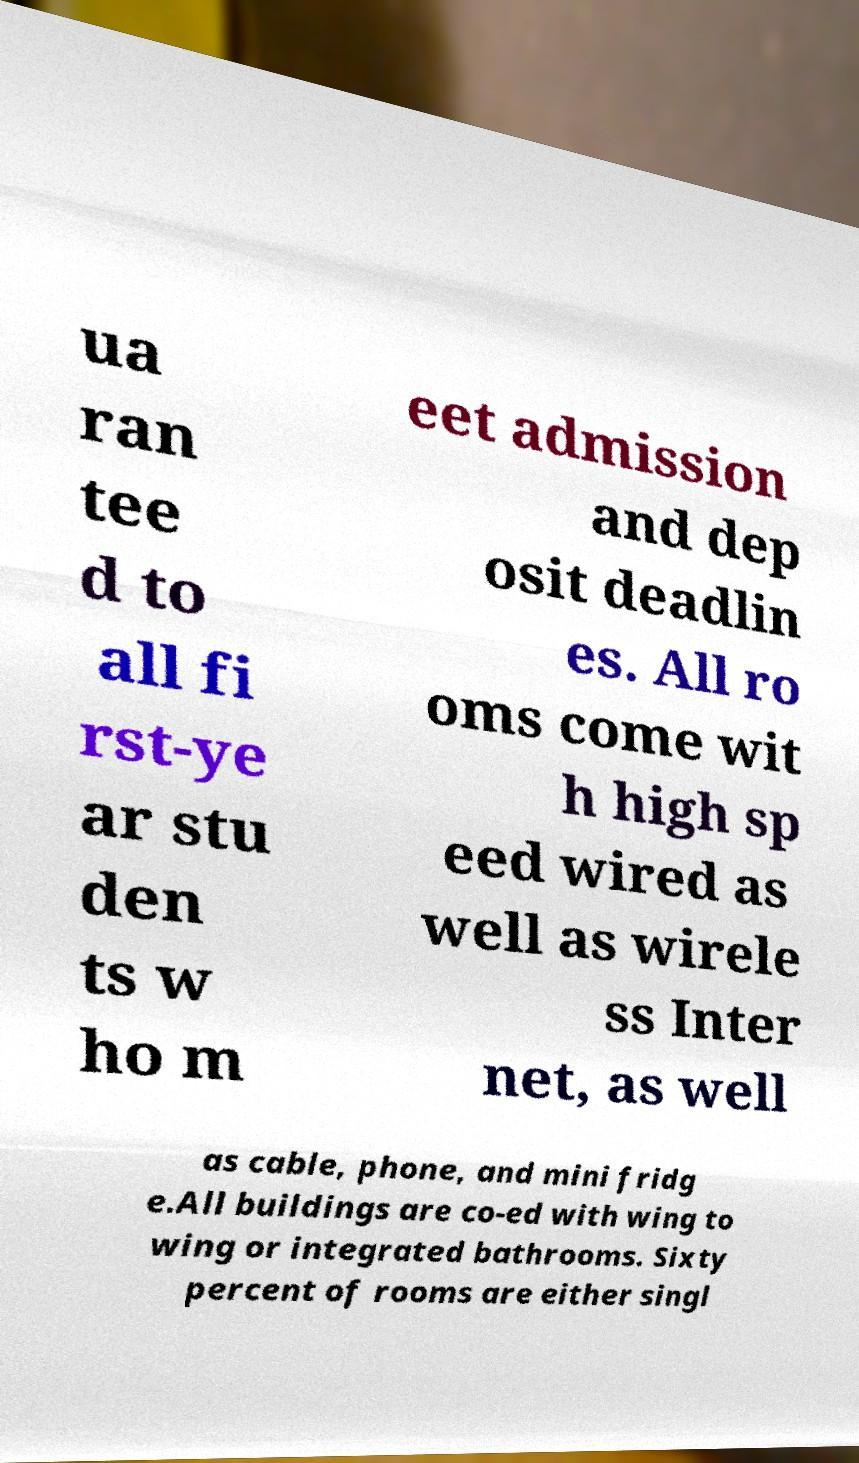Please read and relay the text visible in this image. What does it say? ua ran tee d to all fi rst-ye ar stu den ts w ho m eet admission and dep osit deadlin es. All ro oms come wit h high sp eed wired as well as wirele ss Inter net, as well as cable, phone, and mini fridg e.All buildings are co-ed with wing to wing or integrated bathrooms. Sixty percent of rooms are either singl 